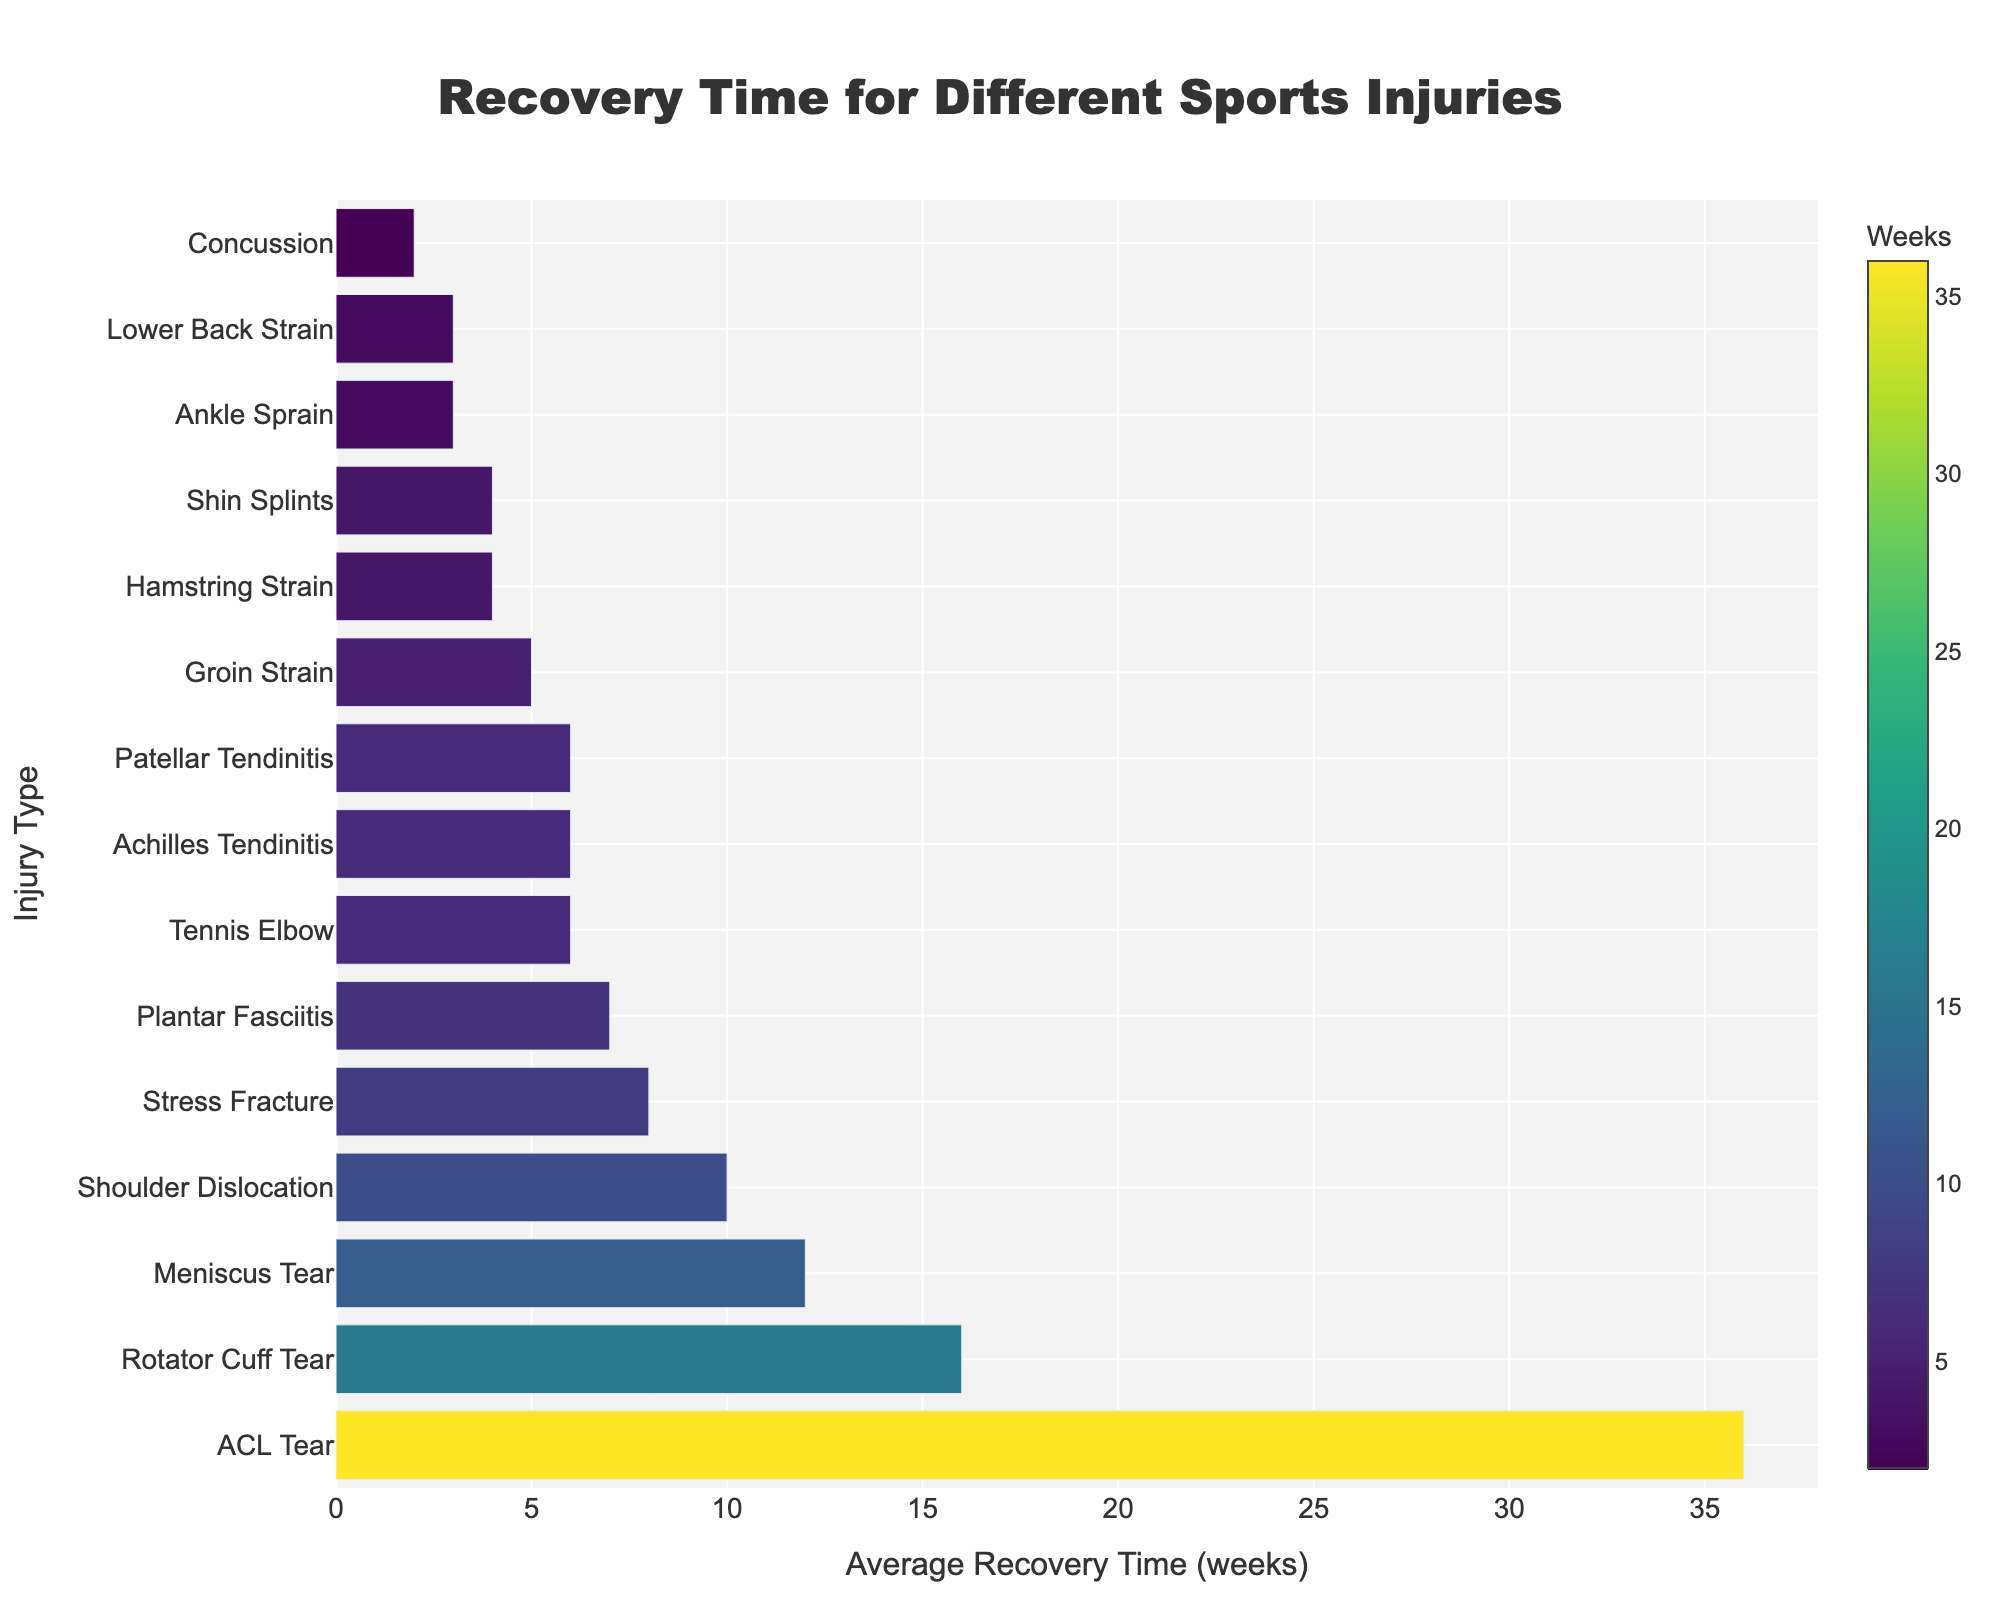What injury type has the longest recovery time? The longest bar in the chart will correspond to the injury type with the longest recovery time. In this chart, the tallest bar represents an ACL Tear.
Answer: ACL Tear What injury type has the shortest recovery time? The shortest bar in the chart will correspond to the injury type with the shortest recovery time. The shortest bar represents a Concussion.
Answer: Concussion How many weeks longer does it take to recover from an ACL Tear compared to an Ankle Sprain? To find out the difference in recovery time, subtract the recovery time for an Ankle Sprain (3 weeks) from the recovery time for an ACL Tear (36 weeks). 36 - 3 = 33 weeks.
Answer: 33 weeks Which injury types take 6 weeks to recover? Look for bars with the value of 6 weeks. The chart shows that Patellar Tendinitis, Tennis Elbow, and Achilles Tendinitis each have bars that reach the value of 6 weeks.
Answer: Patellar Tendinitis, Tennis Elbow, Achilles Tendinitis Is the recovery time for a Groin Strain longer than for a Hamstring Strain? Compare the lengths of the bars for Groin Strain and Hamstring Strain. The bar for Groin Strain (5 weeks) is longer than that for Hamstring Strain (4 weeks).
Answer: Yes Which injuries have a recovery time between 2 and 5 weeks? Identify bars that fall within the 2 to 5 weeks range: Concussion (2 weeks), Ankle Sprain (3 weeks), Hamstring Strain (4 weeks), Shin Splints (4 weeks), and Groin Strain (5 weeks).
Answer: Concussion, Ankle Sprain, Hamstring Strain, Shin Splints, Groin Strain How much longer is the recovery for a Meniscus Tear compared to a Shoulder Dislocation? Subtract the recovery time for Shoulder Dislocation (10 weeks) from that for a Meniscus Tear (12 weeks). 12 - 10 = 2 weeks.
Answer: 2 weeks Which injury type has the median recovery time, and what is the value? To find the median, list the recovery times in ascending order: 2, 3, 3, 4, 4, 5, 6, 6, 6, 7, 8, 10, 12, 16, 36. The median value is the eighth value in this ordered list, which is 6 weeks and corresponds to Achilles Tendinitis, Tennis Elbow, or Patellar Tendinitis.
Answer: Achilles Tendinitis, Patellar Tendinitis, or Tennis Elbow; 6 weeks 